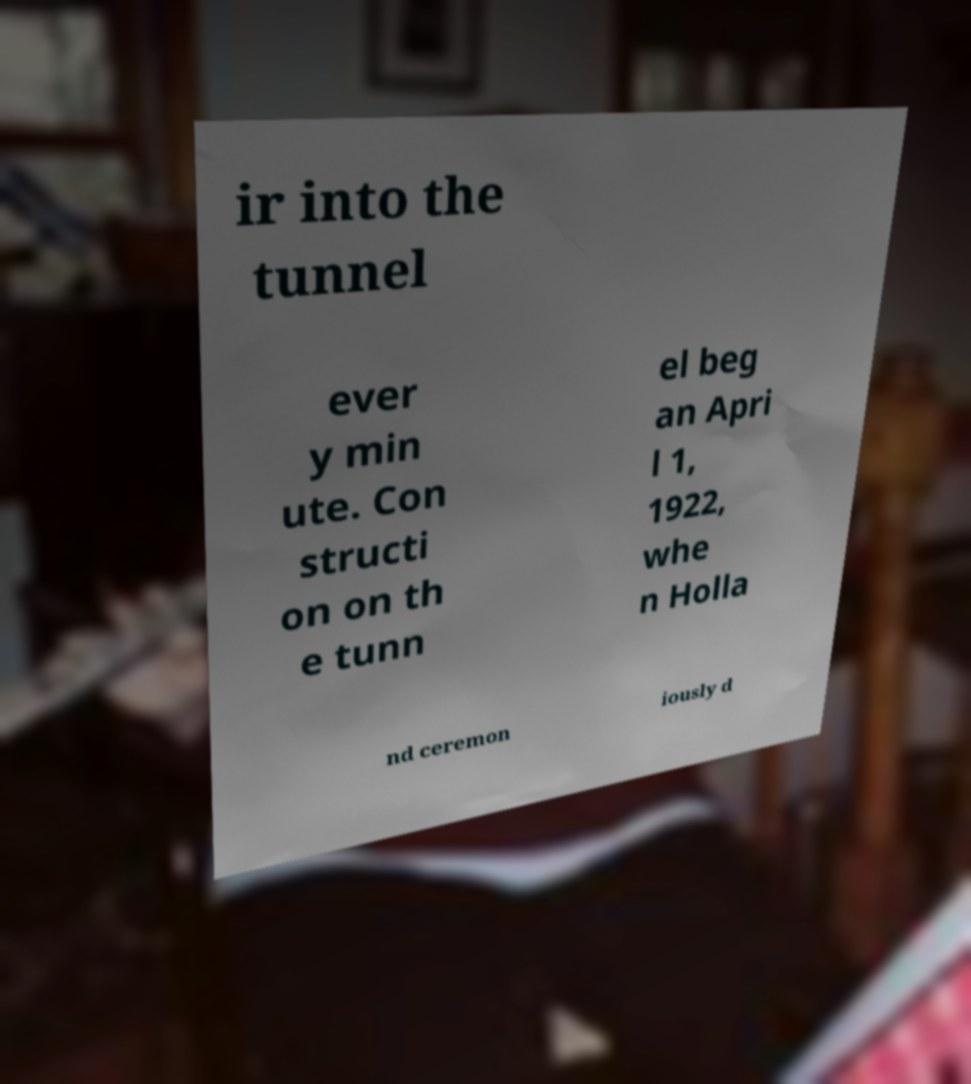Could you assist in decoding the text presented in this image and type it out clearly? ir into the tunnel ever y min ute. Con structi on on th e tunn el beg an Apri l 1, 1922, whe n Holla nd ceremon iously d 